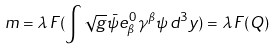Convert formula to latex. <formula><loc_0><loc_0><loc_500><loc_500>m = \lambda \, F ( \int { \sqrt { g } \bar { \psi } e ^ { \, 0 } _ { \beta } \gamma ^ { \beta } \psi \, d ^ { 3 } y } ) = \lambda \, F ( Q )</formula> 